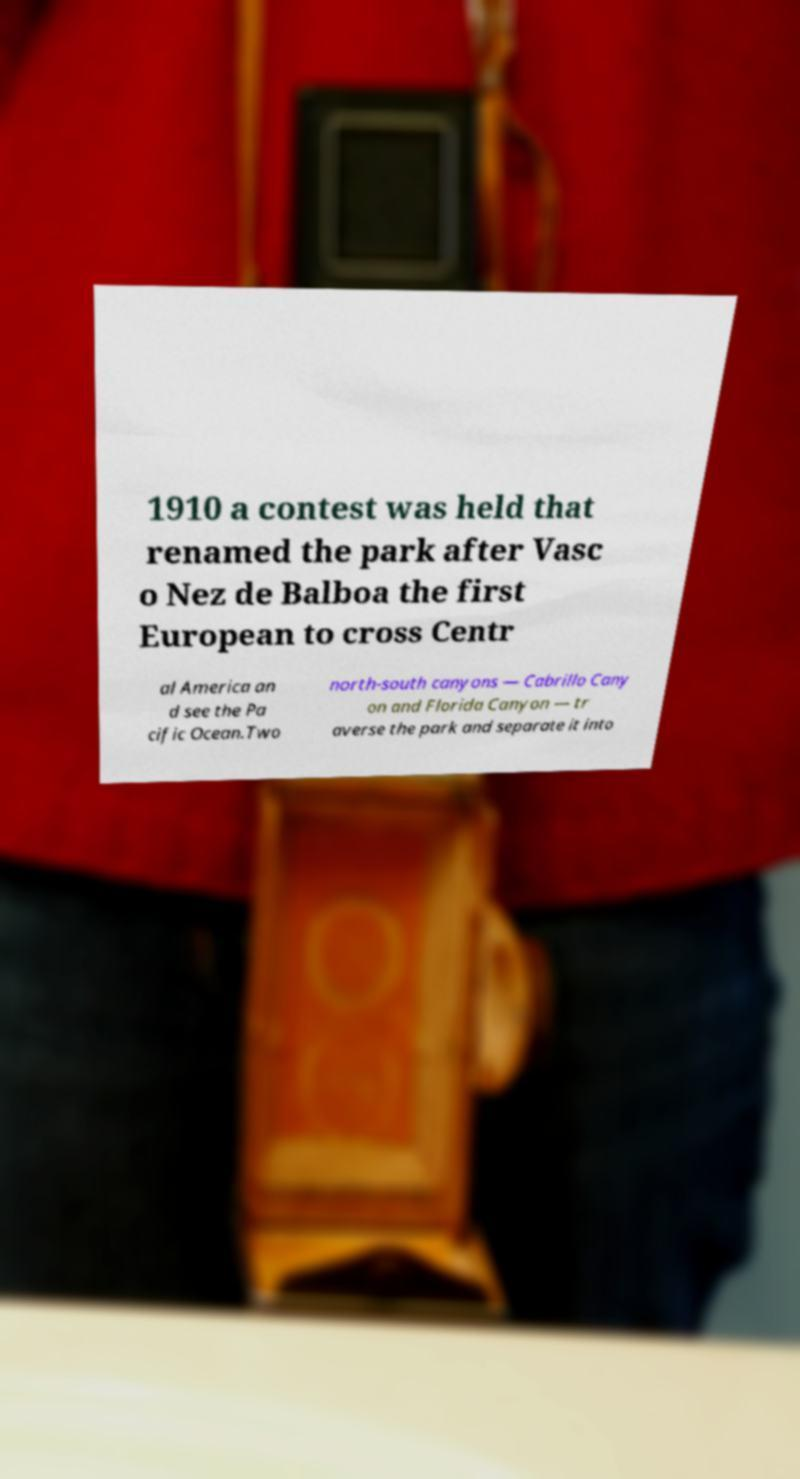Can you read and provide the text displayed in the image?This photo seems to have some interesting text. Can you extract and type it out for me? 1910 a contest was held that renamed the park after Vasc o Nez de Balboa the first European to cross Centr al America an d see the Pa cific Ocean.Two north-south canyons — Cabrillo Cany on and Florida Canyon — tr averse the park and separate it into 